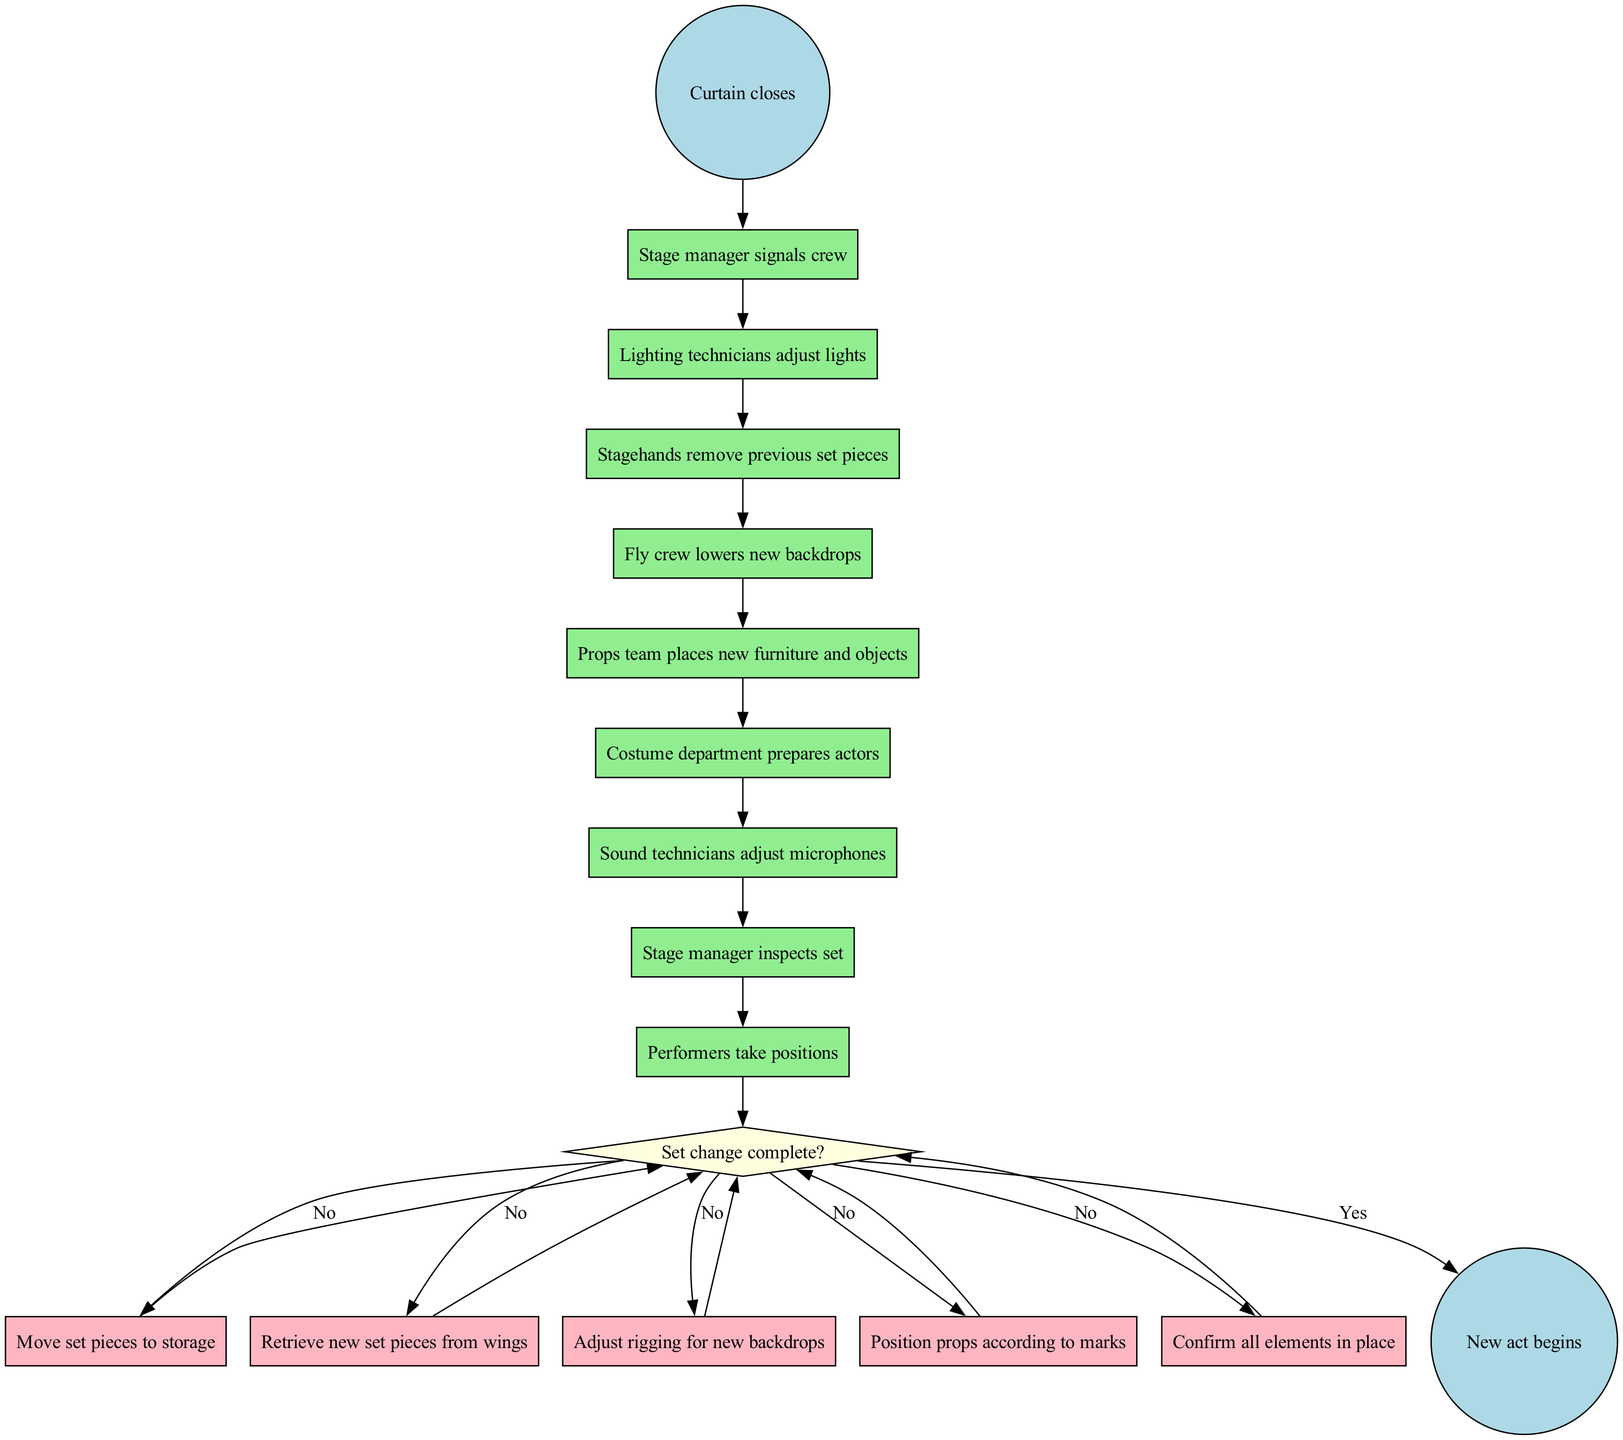What is the initial node in the diagram? The initial node is identified as "Curtain closes," which indicates the starting point of the set change process in the diagram.
Answer: Curtain closes How many activities are listed in the diagram? The diagram includes a total of eight distinct activities. This is determined by counting the items listed under the "activities" section.
Answer: 8 What is the final node in the diagram? The final node is labeled "New act begins," which signifies the endpoint of the process once all set changes are complete.
Answer: New act begins What happens if the set change is not complete? If the set change is not complete, the diagram indicates to "Continue set changes," meaning the process will loop back to address remaining tasks before proceeding.
Answer: Continue set changes Which team adjusts the microphones? The "Sound technicians" are responsible for adjusting the microphones, as noted in the activities listed in the diagram.
Answer: Sound technicians What action follows the stage manager signaling the crew? After the stage manager signals the crew, the next action in the sequence is for the "Lighting technicians" to adjust lights. This is determined by following the flow from the first activity in the diagram.
Answer: Lighting technicians adjust lights What is the condition used to decide if the set change is complete? The condition used in the decision point is "Set change complete?" which helps determine the next action based on whether or not the set change has been finalized.
Answer: Set change complete? What do the stagehands do according to the diagram? The stagehands are tasked with removing previous set pieces as part of the set change process. This is mentioned in the sequential list of activities.
Answer: Remove previous set pieces How many edges are there in the diagram? There are a total of five edges connecting the decision node to various actions and back to the decision, indicating the different paths that can be taken during the set change process.
Answer: 5 